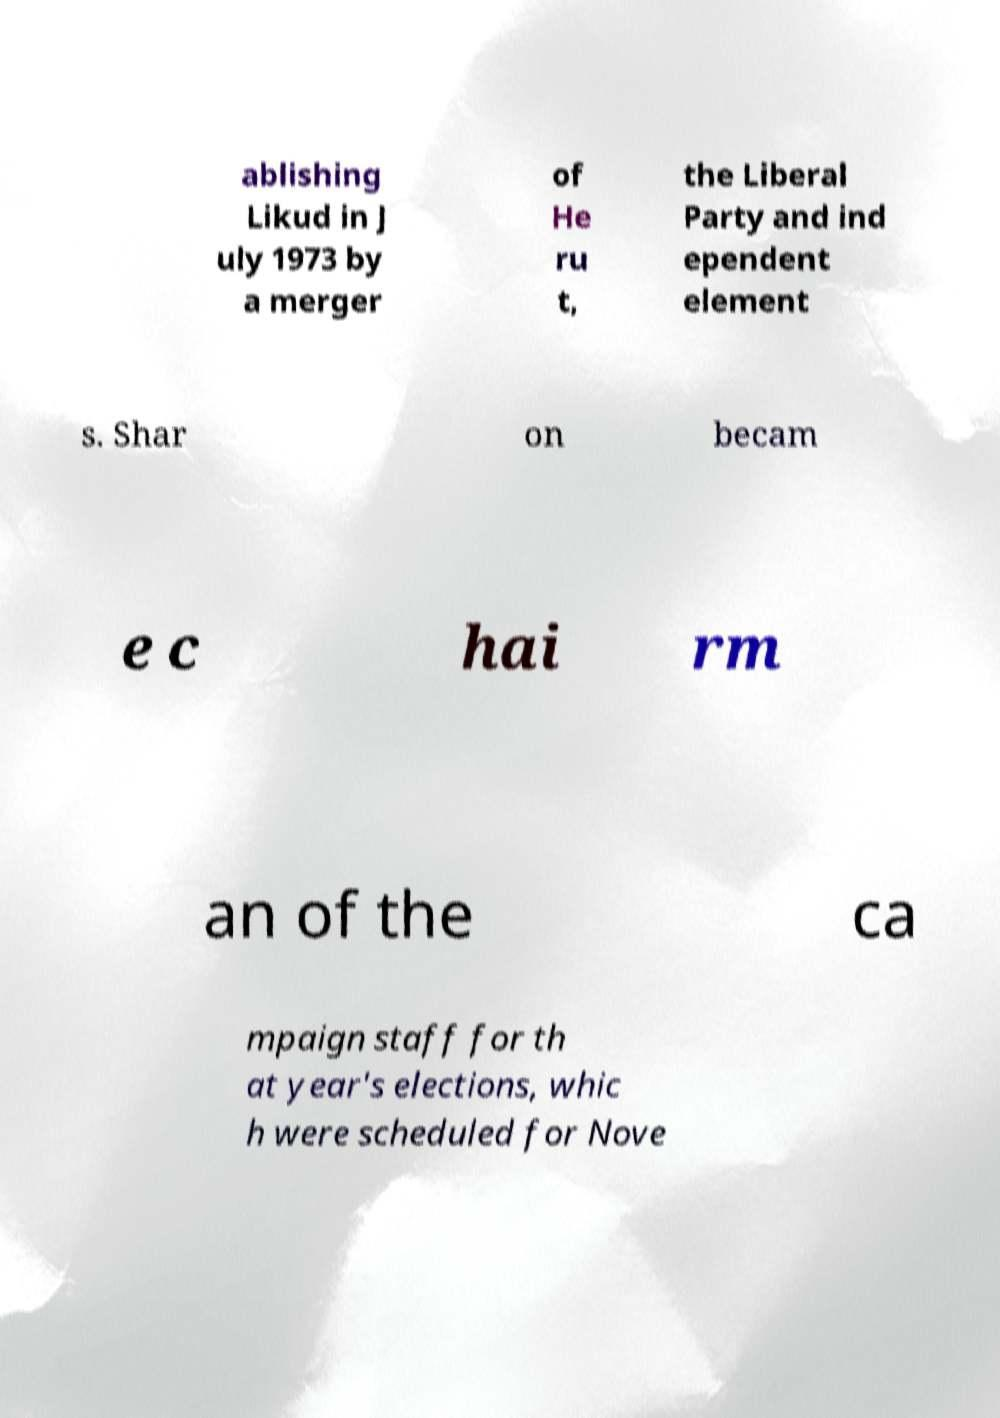For documentation purposes, I need the text within this image transcribed. Could you provide that? ablishing Likud in J uly 1973 by a merger of He ru t, the Liberal Party and ind ependent element s. Shar on becam e c hai rm an of the ca mpaign staff for th at year's elections, whic h were scheduled for Nove 